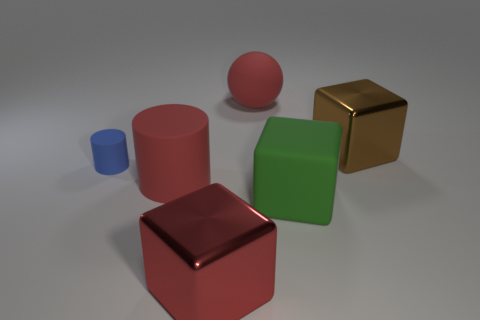What shape is the large shiny object that is the same color as the large matte ball?
Your answer should be very brief. Cube. Are there any tiny rubber things of the same color as the ball?
Your response must be concise. No. There is a large red thing to the right of the red metal block; does it have the same shape as the big red matte thing left of the matte ball?
Your response must be concise. No. The cylinder that is the same color as the large sphere is what size?
Ensure brevity in your answer.  Large. How many other objects are there of the same size as the red sphere?
Your answer should be very brief. 4. There is a big matte sphere; is its color the same as the large metallic cube on the left side of the large red matte sphere?
Provide a succinct answer. Yes. Are there fewer big matte blocks on the left side of the large red cylinder than large rubber balls to the left of the red matte ball?
Keep it short and to the point. No. What color is the large rubber thing that is in front of the big brown metallic cube and left of the large green block?
Provide a short and direct response. Red. Does the blue cylinder have the same size as the metallic object that is to the left of the matte sphere?
Your answer should be very brief. No. There is a big red matte thing behind the blue cylinder; what shape is it?
Offer a terse response. Sphere. 